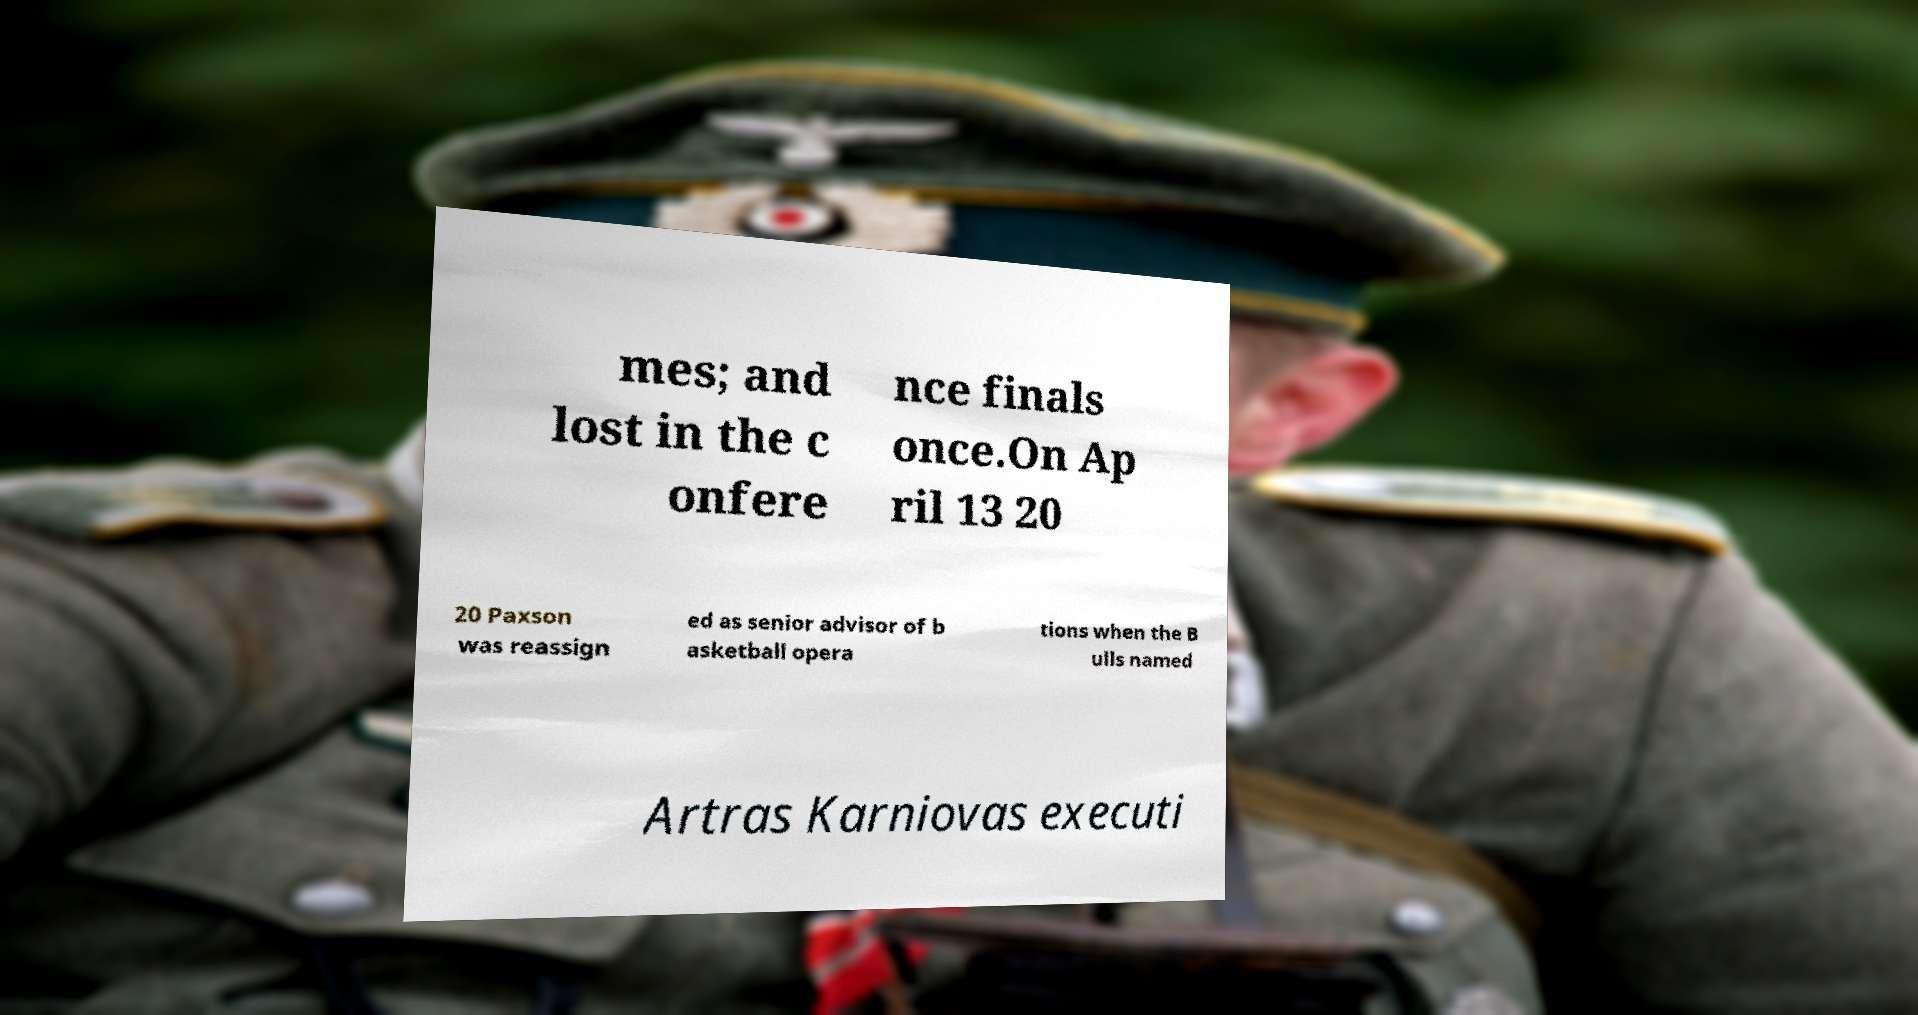Please identify and transcribe the text found in this image. mes; and lost in the c onfere nce finals once.On Ap ril 13 20 20 Paxson was reassign ed as senior advisor of b asketball opera tions when the B ulls named Artras Karniovas executi 